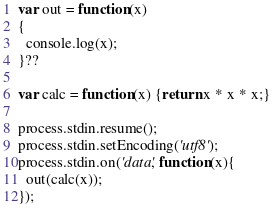Convert code to text. <code><loc_0><loc_0><loc_500><loc_500><_JavaScript_>var out = function(x)
{
  console.log(x);
}??

var calc = function(x) {return x * x * x;}

process.stdin.resume();
process.stdin.setEncoding('utf8');
process.stdin.on('data', function(x){
  out(calc(x));
});</code> 